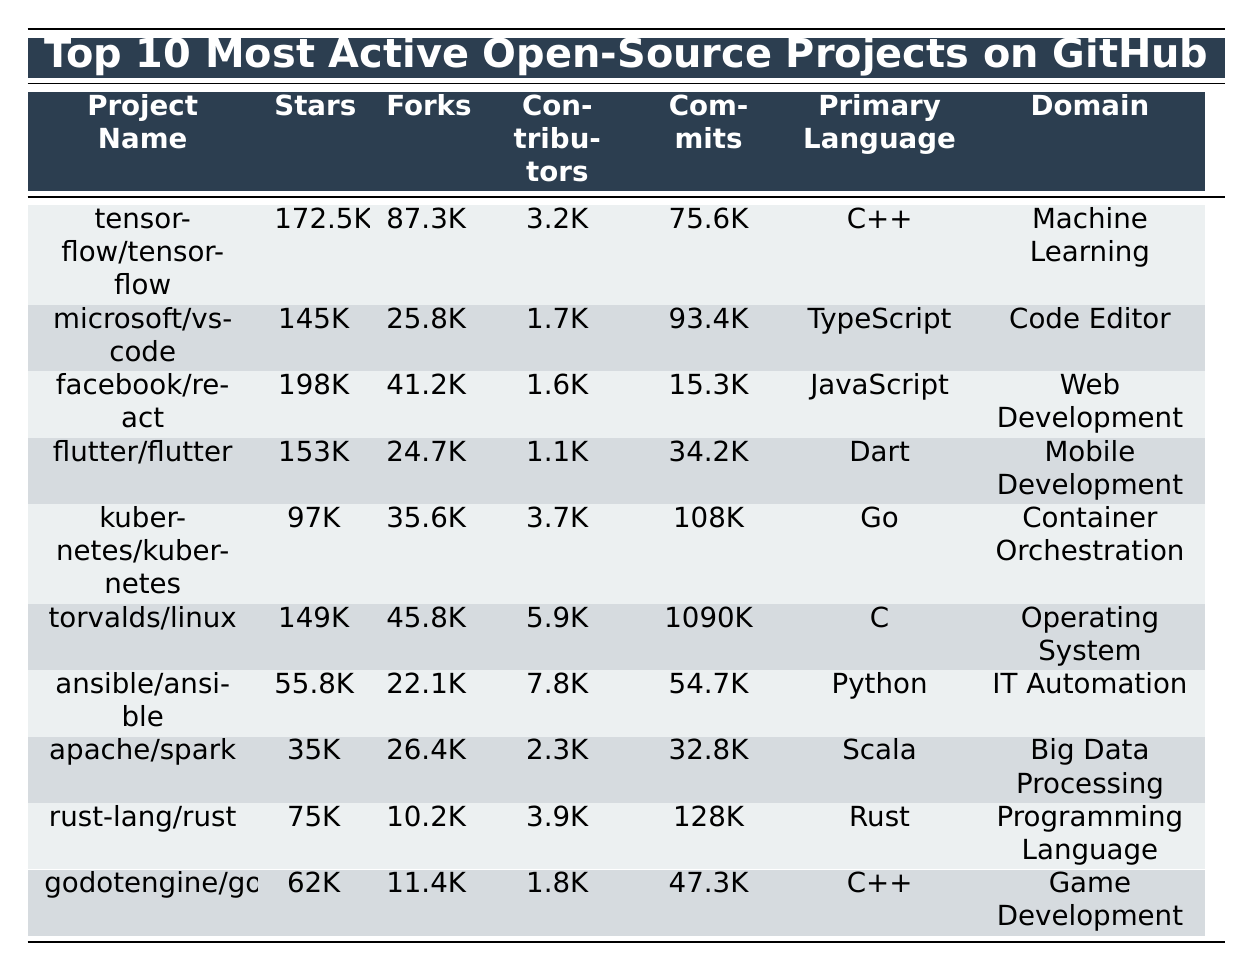What is the project with the highest number of stars? Looking at the "Stars" column, the project "facebook/react" has 198,000 stars, which is the highest among all the projects listed.
Answer: facebook/react How many forks does the "flutter/flutter" project have? The "forks" column indicates that the "flutter/flutter" project has 24,700 forks.
Answer: 24,700 Is the primary language of the "ansible/ansible" project Python? Yes, the "Primary Language" column shows that "ansible/ansible" is indeed written in Python.
Answer: Yes Which project has the most contributors? The "Contributors" column reveals that "torvalds/linux" has 5,900 contributors, which is the highest number in the table.
Answer: torvalds/linux What is the average number of commits across all projects? The total number of commits is 1,214,300 (75,600 + 93,400 + 15,300 + 34,200 + 108,000 + 1,090,000 + 54,700 + 32,800 + 128,000 + 47,300 = 1,214,300), and there are 10 projects. Therefore, the average is 1,214,300 / 10 = 121,430.
Answer: 121,430 Does the "kubernetes/kubernetes" project have more stars or forks? By comparing the "Stars" (97,000) and "Forks" (35,600) columns, we see that "kubernetes/kubernetes" has more stars than forks.
Answer: Stars Which project has the least number of contributors? The "Contributors" column shows that "flutter/flutter" has the least contributors with 1,100.
Answer: flutter/flutter What is the difference in stars between "facebook/react" and "microsoft/vscode"? The stars for "facebook/react" is 198,000 and for "microsoft/vscode" it is 145,000, resulting in a difference of 198,000 - 145,000 = 53,000.
Answer: 53,000 Are there any projects that use the C++ programming language? Yes, "tensorflow/tensorflow" and "godotengine/godot" both use C++.
Answer: Yes Which project has the most commits overall? The total number of commits for "torvalds/linux" is 1,090,000, making it have the most commits overall compared to others listed.
Answer: torvalds/linux What percent of contributors does "godotengine/godot" have compared to the "facebook/react"? "godotengine/godot" has 1,800 contributors while "facebook/react" has 1,600 contributors. The percentage is (1,800 / 1,600) * 100 = 112.5%.
Answer: 112.5% 